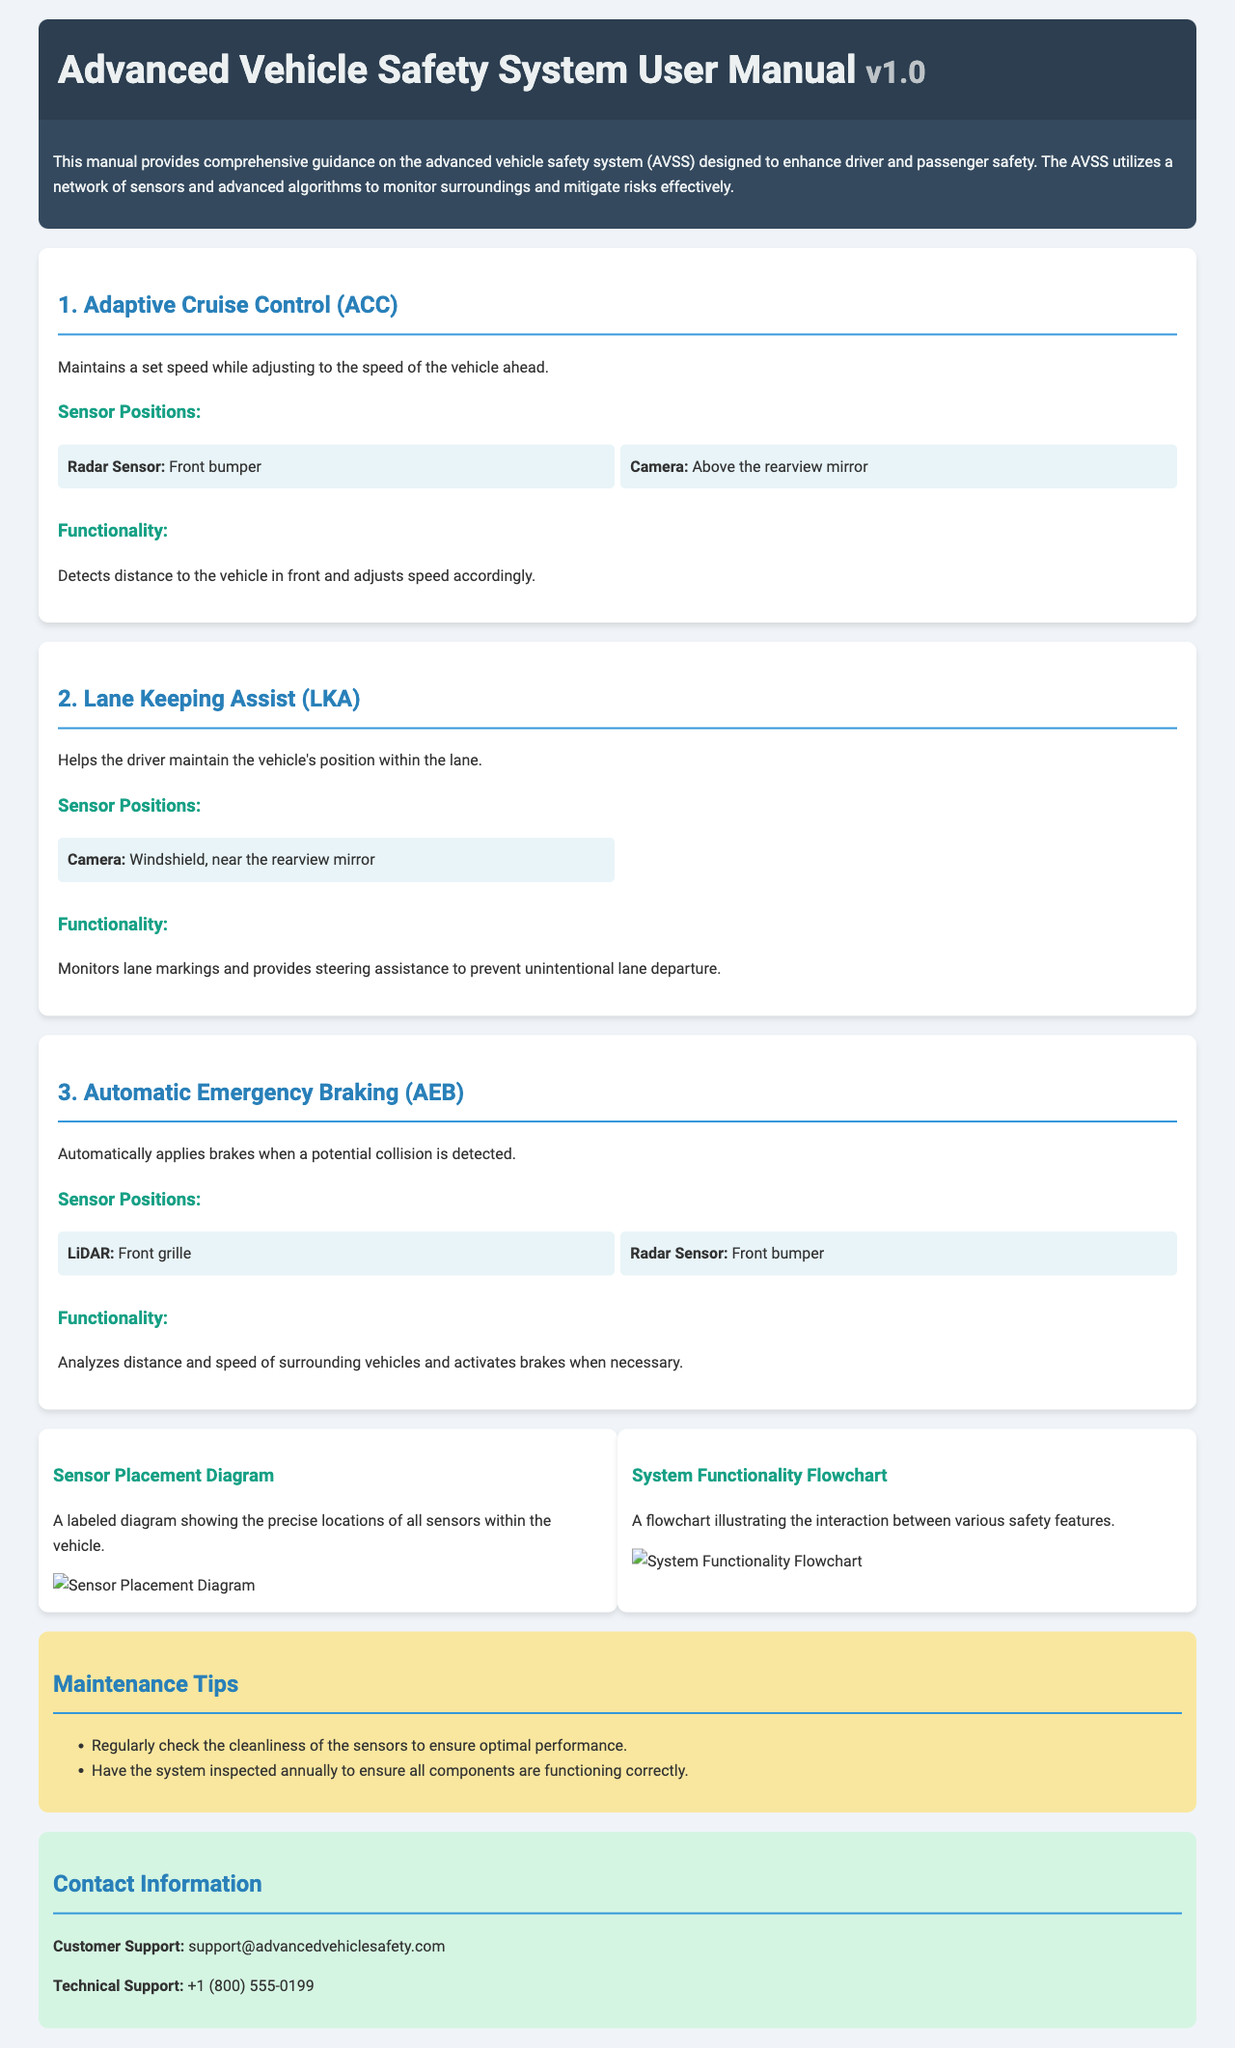What is the version of the user manual? The version is indicated in the header section of the manual, labeled as v1.0.
Answer: v1.0 Where is the radar sensor positioned for Adaptive Cruise Control? The position of the radar sensor for Adaptive Cruise Control is located at the front bumper.
Answer: Front bumper What does the Lane Keeping Assist help the driver with? The Lane Keeping Assist helps the driver maintain the vehicle's position within the lane, as stated in its description.
Answer: Maintain position within the lane How does the Automatic Emergency Braking function? The Automatic Emergency Braking automatically applies brakes when a potential collision is detected, according to its functionality description.
Answer: Applies brakes when collision detected What is a recommended maintenance tip for the safety system? The manual suggests regularly checking the cleanliness of the sensors to ensure optimal performance.
Answer: Regularly check cleanliness of sensors What type of diagram shows the precise locations of all sensors? The manual refers to a "Sensor Placement Diagram" that illustrates the precise locations of all sensors within the vehicle.
Answer: Sensor Placement Diagram What is the contact email for customer support? The email for customer support is listed under the contact information section of the manual.
Answer: support@advancedvehiclesafety.com How many steps are included in the functionality flowchart? The number of steps in the flowchart is not specified; the focus is on the interaction between various safety features without enumerating steps.
Answer: Not specified Which feature uses LiDAR as a sensor? The Automatic Emergency Braking feature utilizes LiDAR, as mentioned in its sensor positions.
Answer: Automatic Emergency Braking 